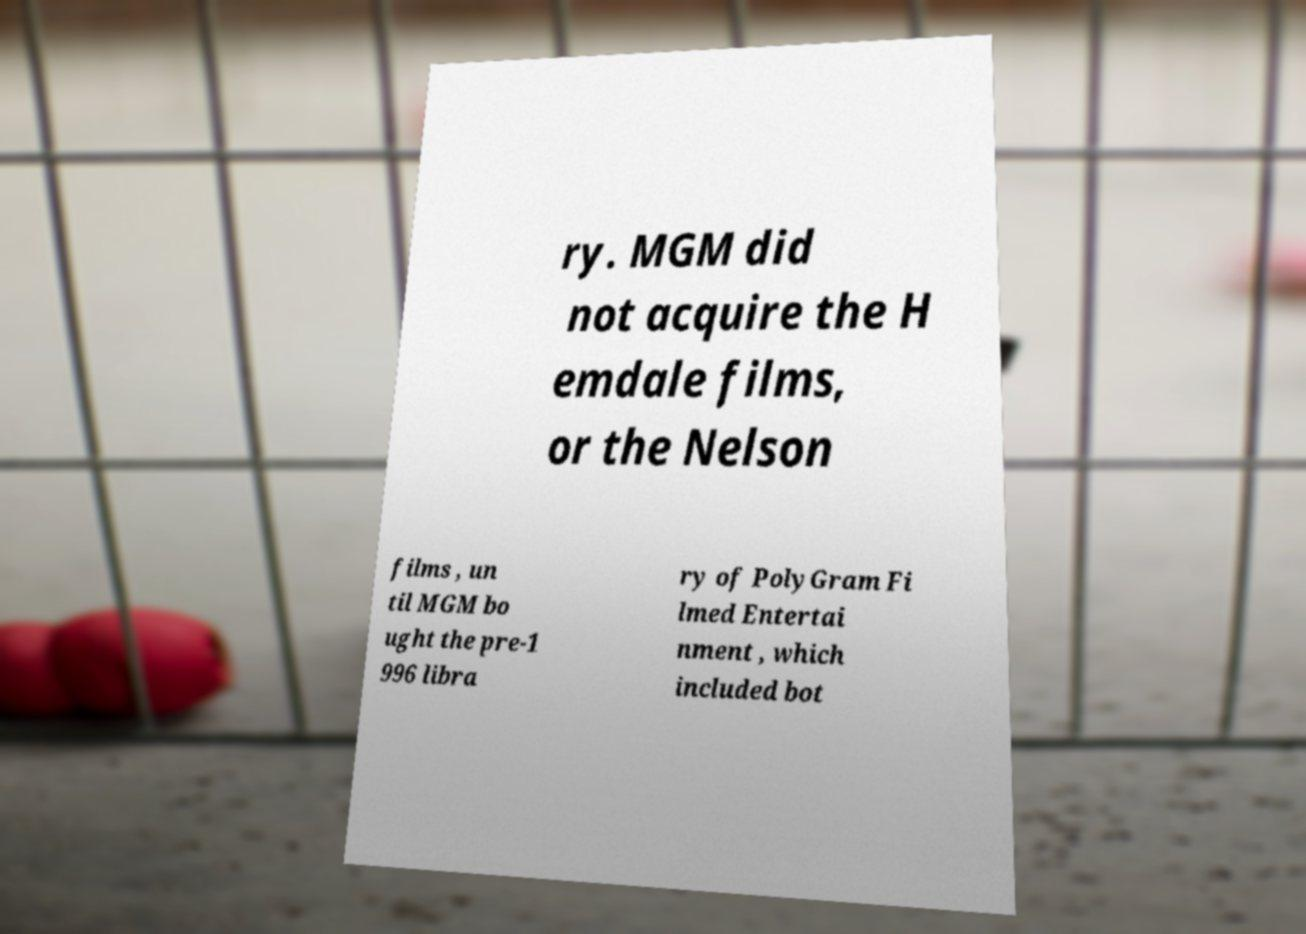For documentation purposes, I need the text within this image transcribed. Could you provide that? ry. MGM did not acquire the H emdale films, or the Nelson films , un til MGM bo ught the pre-1 996 libra ry of PolyGram Fi lmed Entertai nment , which included bot 